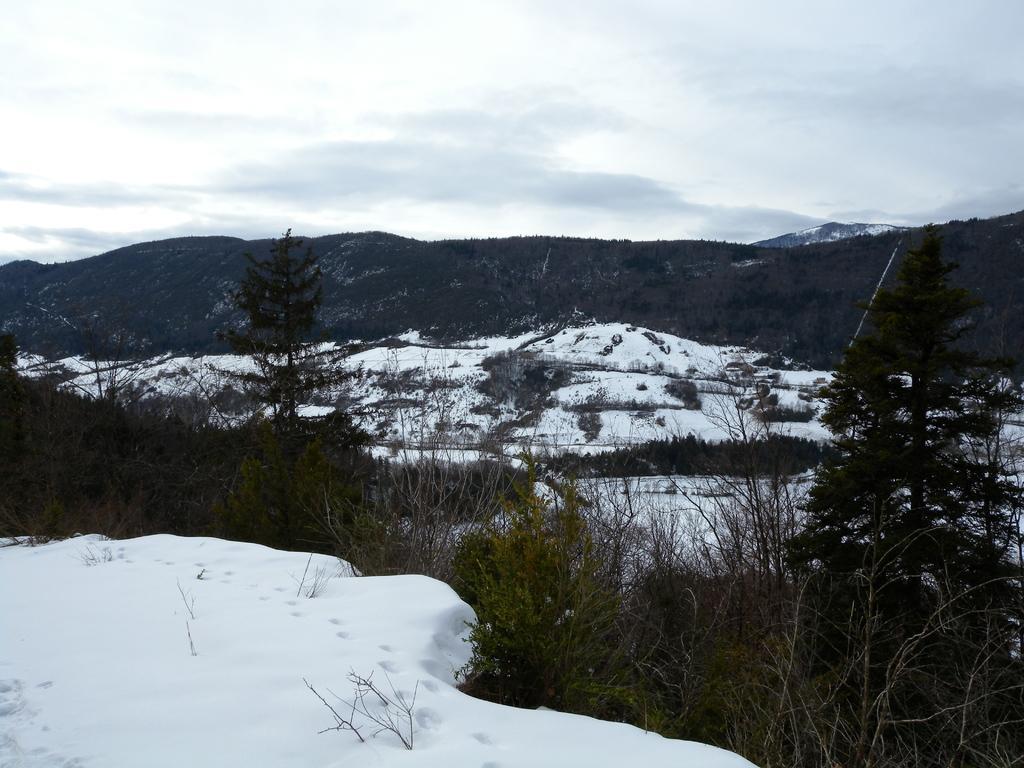Please provide a concise description of this image. At the bottom of the picture, we see ice and trees. There are hills, trees and ice in the background. At the top of the picture, we see the sky. 